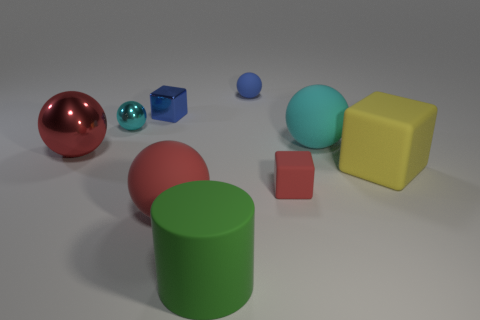How many small cyan things have the same shape as the large cyan object?
Make the answer very short. 1. What number of matte cubes are there?
Keep it short and to the point. 2. There is a small sphere on the left side of the blue shiny object; what is its color?
Offer a terse response. Cyan. There is a tiny thing that is in front of the tiny sphere that is to the left of the large matte cylinder; what is its color?
Provide a succinct answer. Red. There is a metallic ball that is the same size as the cyan rubber object; what is its color?
Give a very brief answer. Red. How many big things are on the left side of the big yellow rubber block and on the right side of the small blue shiny object?
Offer a very short reply. 3. The tiny matte thing that is the same color as the small metallic cube is what shape?
Offer a terse response. Sphere. The sphere that is both to the right of the large red metallic sphere and on the left side of the small blue block is made of what material?
Ensure brevity in your answer.  Metal. Are there fewer cyan things to the right of the big cylinder than large red spheres left of the small shiny ball?
Your response must be concise. No. What is the size of the red thing that is the same material as the small cyan thing?
Your answer should be very brief. Large. 